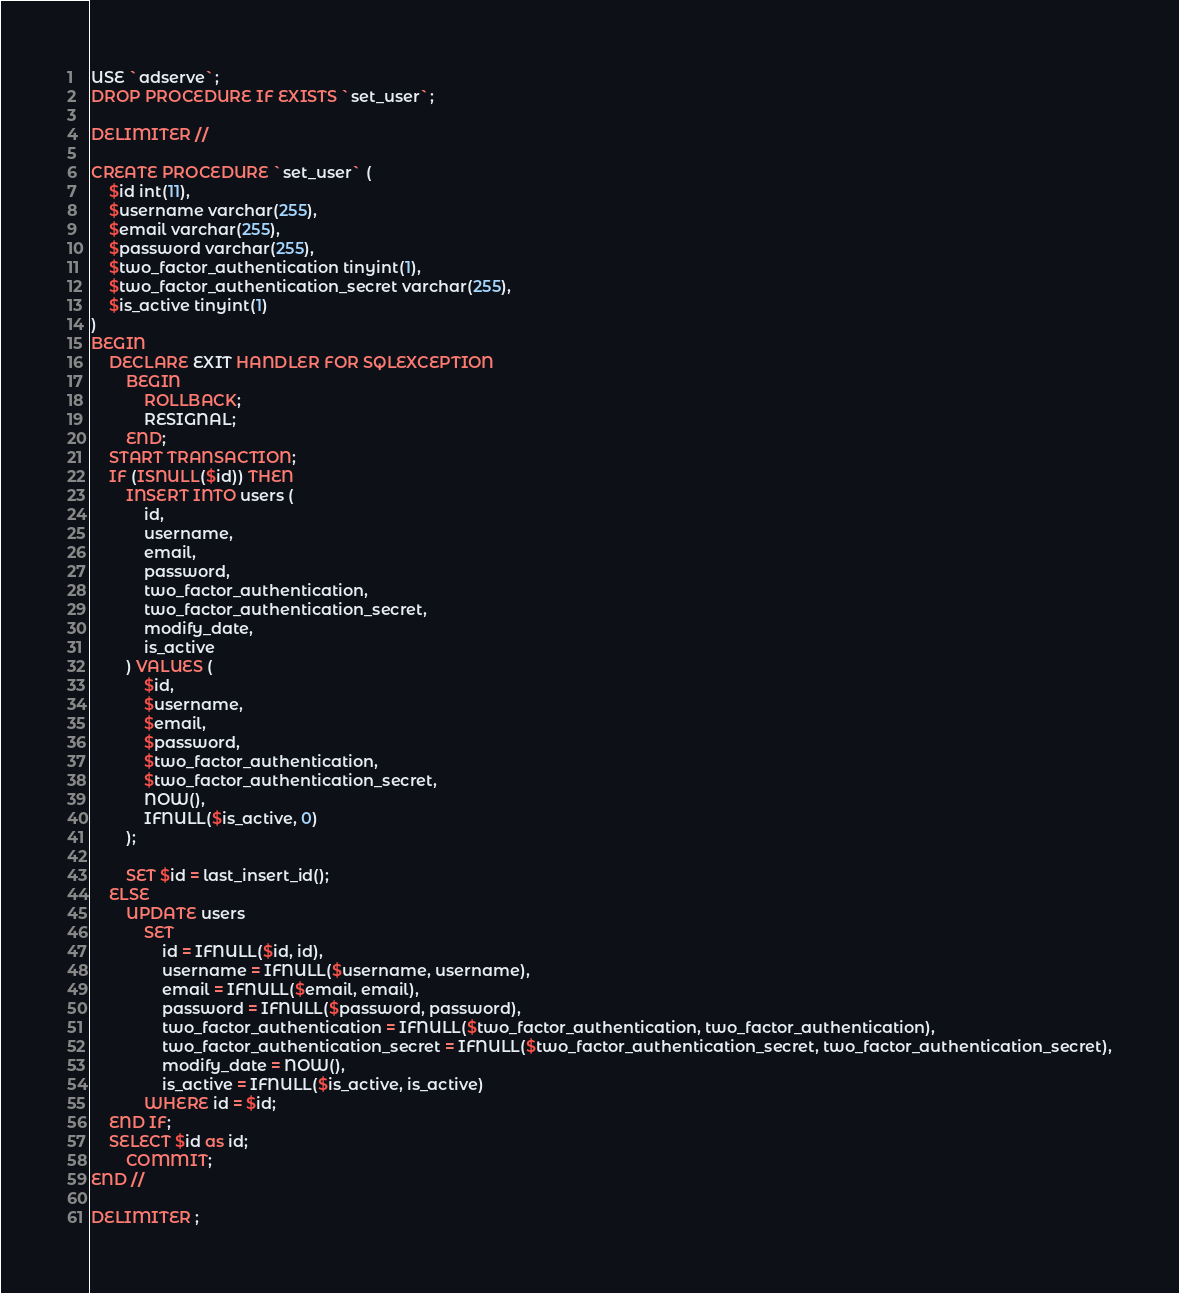Convert code to text. <code><loc_0><loc_0><loc_500><loc_500><_SQL_>USE `adserve`;
DROP PROCEDURE IF EXISTS `set_user`;

DELIMITER //

CREATE PROCEDURE `set_user` (
    $id int(11),
    $username varchar(255),
    $email varchar(255),
    $password varchar(255),
    $two_factor_authentication tinyint(1),
    $two_factor_authentication_secret varchar(255),
    $is_active tinyint(1)
)
BEGIN
    DECLARE EXIT HANDLER FOR SQLEXCEPTION
        BEGIN
            ROLLBACK;
            RESIGNAL;
        END;
    START TRANSACTION;
    IF (ISNULL($id)) THEN
        INSERT INTO users (
            id,
            username,
            email,
            password,
            two_factor_authentication,
            two_factor_authentication_secret,
            modify_date,
            is_active
        ) VALUES (
            $id,
            $username,
            $email,
            $password,
            $two_factor_authentication,
            $two_factor_authentication_secret,
            NOW(),
            IFNULL($is_active, 0)
        );

        SET $id = last_insert_id();
    ELSE
        UPDATE users
            SET
                id = IFNULL($id, id),
                username = IFNULL($username, username),
                email = IFNULL($email, email),
                password = IFNULL($password, password),
                two_factor_authentication = IFNULL($two_factor_authentication, two_factor_authentication),
                two_factor_authentication_secret = IFNULL($two_factor_authentication_secret, two_factor_authentication_secret),
                modify_date = NOW(),
                is_active = IFNULL($is_active, is_active)
            WHERE id = $id;
    END IF;
    SELECT $id as id;
        COMMIT;
END //

DELIMITER ;
</code> 